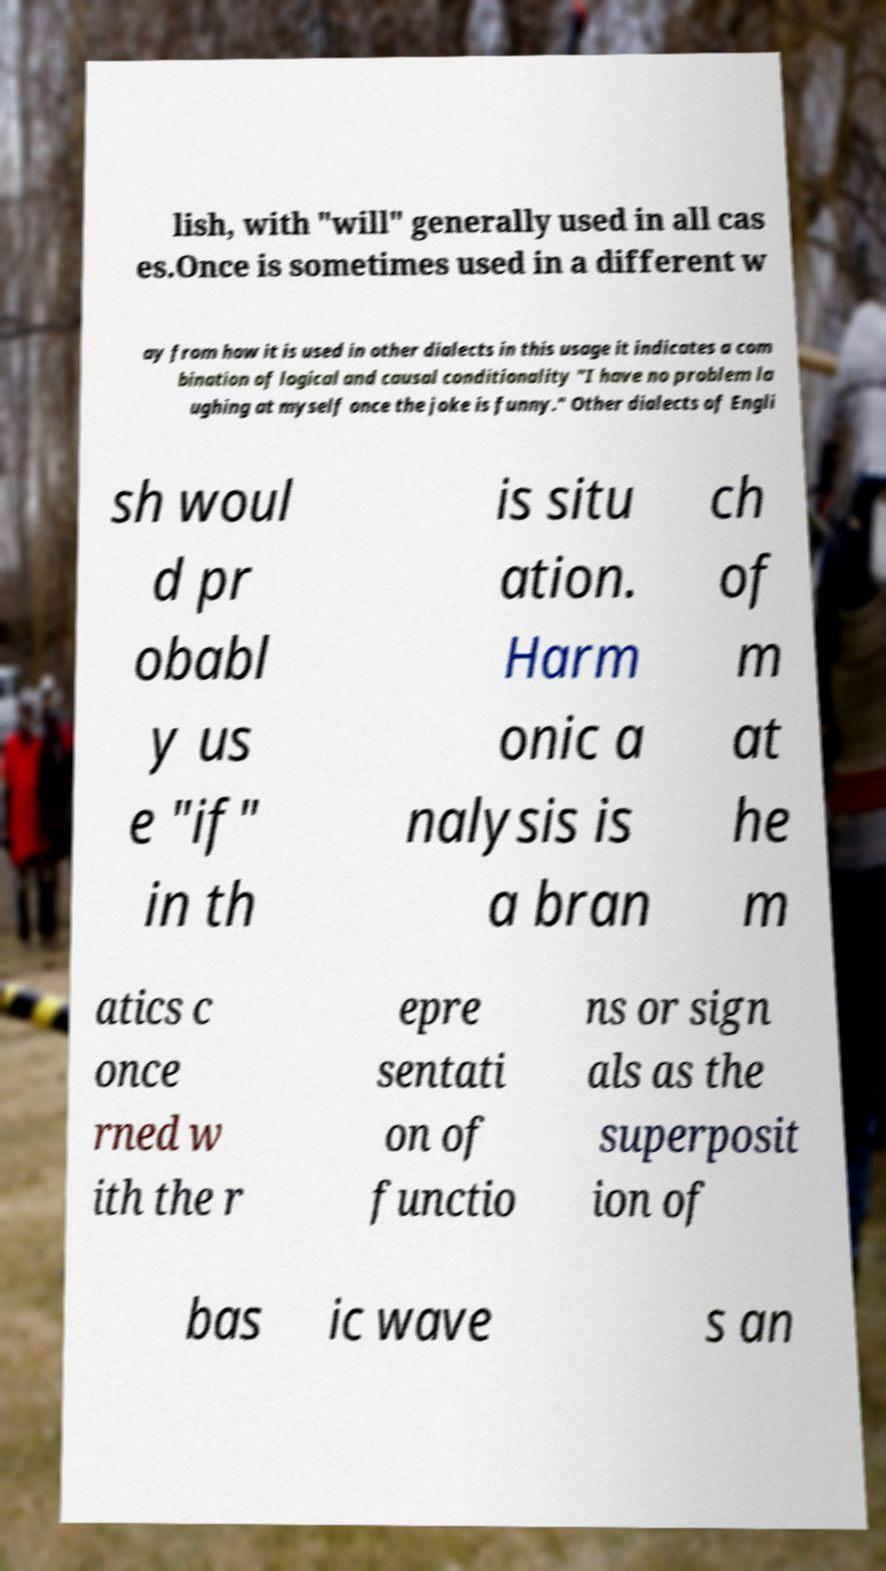Can you accurately transcribe the text from the provided image for me? lish, with "will" generally used in all cas es.Once is sometimes used in a different w ay from how it is used in other dialects in this usage it indicates a com bination of logical and causal conditionality "I have no problem la ughing at myself once the joke is funny." Other dialects of Engli sh woul d pr obabl y us e "if" in th is situ ation. Harm onic a nalysis is a bran ch of m at he m atics c once rned w ith the r epre sentati on of functio ns or sign als as the superposit ion of bas ic wave s an 